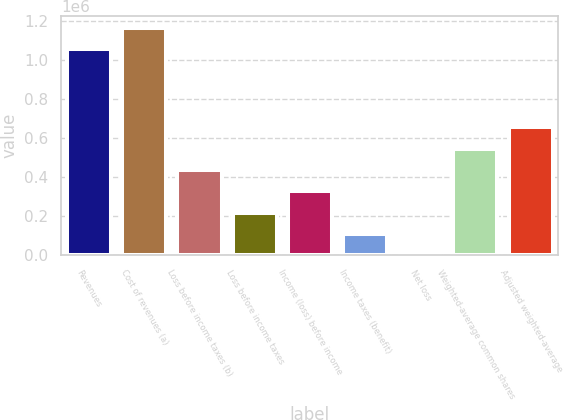Convert chart to OTSL. <chart><loc_0><loc_0><loc_500><loc_500><bar_chart><fcel>Revenues<fcel>Cost of revenues (a)<fcel>Loss before income taxes (b)<fcel>Loss before income taxes<fcel>Income (loss) before income<fcel>Income taxes (benefit)<fcel>Net loss<fcel>Weighted-average common shares<fcel>Adjusted weighted-average<nl><fcel>1.05679e+06<fcel>1.16607e+06<fcel>437100<fcel>218551<fcel>327825<fcel>109276<fcel>1.15<fcel>546375<fcel>655649<nl></chart> 